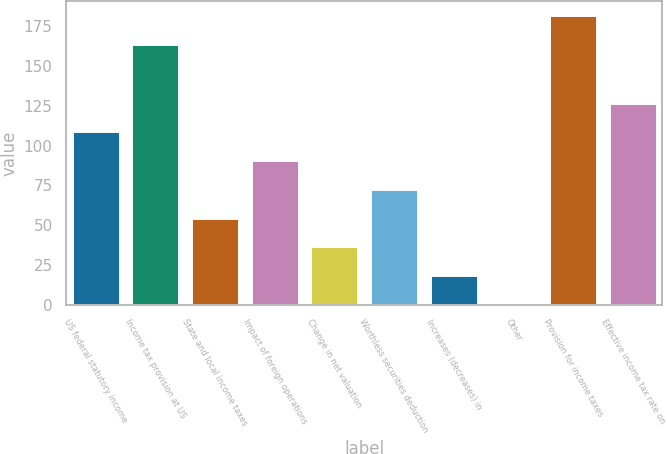Convert chart to OTSL. <chart><loc_0><loc_0><loc_500><loc_500><bar_chart><fcel>US federal statutory income<fcel>Income tax provision at US<fcel>State and local income taxes<fcel>Impact of foreign operations<fcel>Change in net valuation<fcel>Worthless securities deduction<fcel>Increases (decreases) in<fcel>Other<fcel>Provision for income taxes<fcel>Effective income tax rate on<nl><fcel>108.96<fcel>163.8<fcel>54.78<fcel>90.9<fcel>36.72<fcel>72.84<fcel>18.66<fcel>0.6<fcel>181.86<fcel>127.02<nl></chart> 